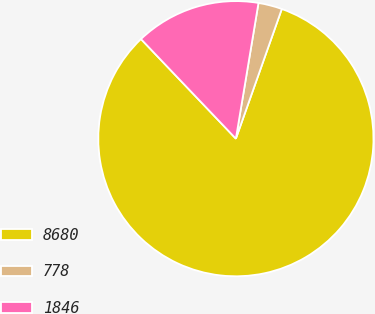Convert chart. <chart><loc_0><loc_0><loc_500><loc_500><pie_chart><fcel>8680<fcel>778<fcel>1846<nl><fcel>82.47%<fcel>2.79%<fcel>14.74%<nl></chart> 